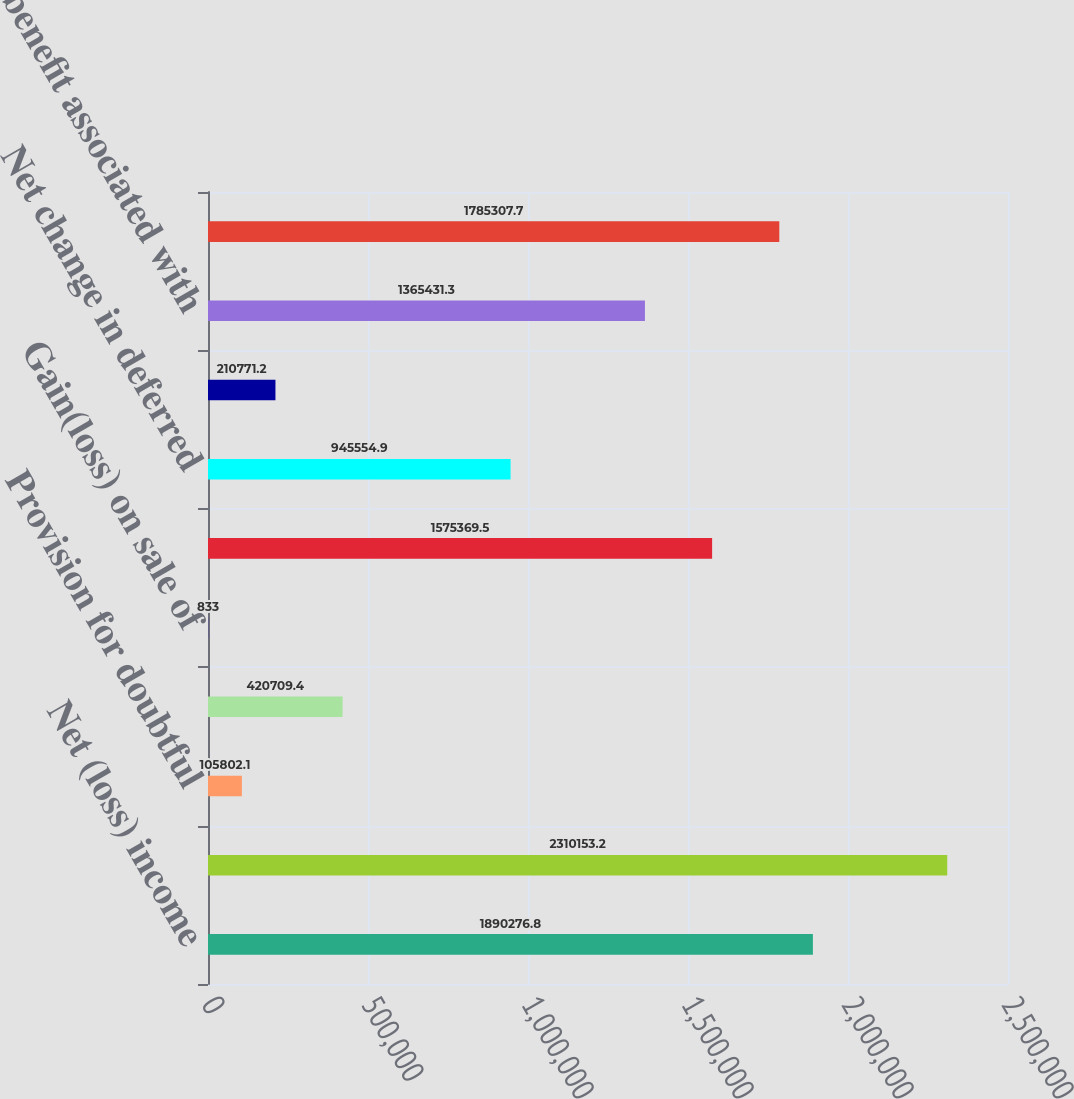Convert chart to OTSL. <chart><loc_0><loc_0><loc_500><loc_500><bar_chart><fcel>Net (loss) income<fcel>Amortization and depreciation<fcel>Provision for doubtful<fcel>Write-downof long term<fcel>Gain(loss) on sale of<fcel>Deferred income taxes<fcel>Net change in deferred<fcel>In-process research and<fcel>Tax benefit associated with<fcel>Accounts receivable<nl><fcel>1.89028e+06<fcel>2.31015e+06<fcel>105802<fcel>420709<fcel>833<fcel>1.57537e+06<fcel>945555<fcel>210771<fcel>1.36543e+06<fcel>1.78531e+06<nl></chart> 